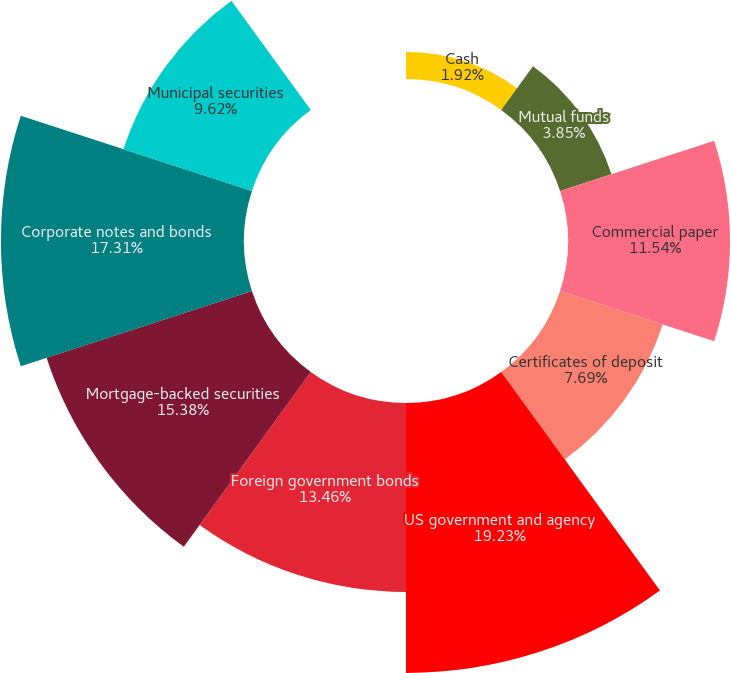<chart> <loc_0><loc_0><loc_500><loc_500><pie_chart><fcel>Cash<fcel>Mutual funds<fcel>Commercial paper<fcel>Certificates of deposit<fcel>US government and agency<fcel>Foreign government bonds<fcel>Mortgage-backed securities<fcel>Corporate notes and bonds<fcel>Municipal securities<fcel>Common and preferred stock<nl><fcel>1.92%<fcel>3.85%<fcel>11.54%<fcel>7.69%<fcel>19.23%<fcel>13.46%<fcel>15.38%<fcel>17.31%<fcel>9.62%<fcel>0.0%<nl></chart> 